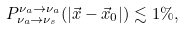<formula> <loc_0><loc_0><loc_500><loc_500>P _ { \nu _ { a } \rightarrow \nu _ { s } } ^ { \nu _ { a } \rightarrow \nu _ { a } } ( | \vec { x } - \vec { x } _ { 0 } | ) \lesssim 1 \% ,</formula> 